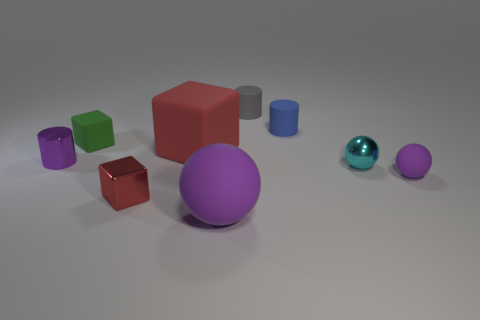Subtract all purple spheres. How many spheres are left? 1 Subtract all gray cylinders. How many cylinders are left? 2 Subtract all blocks. How many objects are left? 6 Subtract 2 cylinders. How many cylinders are left? 1 Subtract all red balls. Subtract all brown cubes. How many balls are left? 3 Subtract all green blocks. How many yellow cylinders are left? 0 Subtract all tiny metallic balls. Subtract all big red blocks. How many objects are left? 7 Add 7 red things. How many red things are left? 9 Add 8 metallic cubes. How many metallic cubes exist? 9 Subtract 1 gray cylinders. How many objects are left? 8 